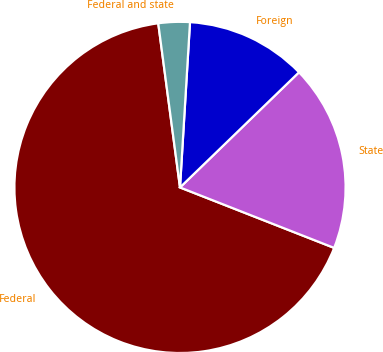Convert chart to OTSL. <chart><loc_0><loc_0><loc_500><loc_500><pie_chart><fcel>Federal<fcel>State<fcel>Foreign<fcel>Federal and state<nl><fcel>66.96%<fcel>18.19%<fcel>11.8%<fcel>3.06%<nl></chart> 